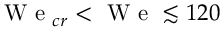<formula> <loc_0><loc_0><loc_500><loc_500>W e _ { c r } < W e \lesssim 1 2 0</formula> 